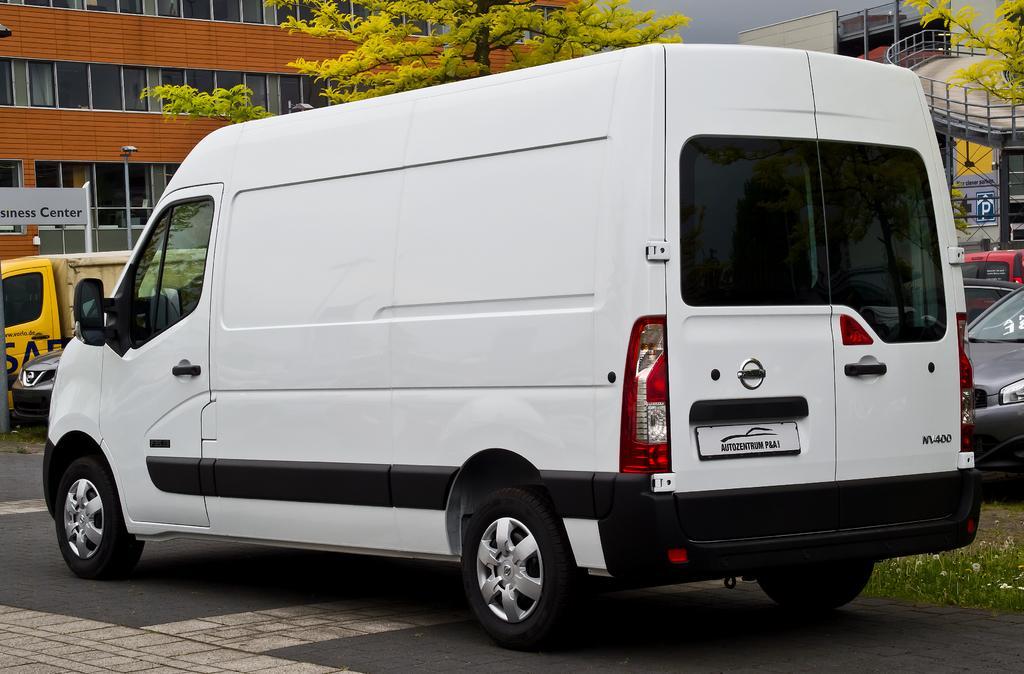In one or two sentences, can you explain what this image depicts? This is the bag, which is white in color. Here is the building with windows. These are the trees. This looks like a flyover. In the background, I can see the cars. 